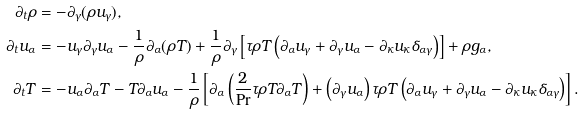Convert formula to latex. <formula><loc_0><loc_0><loc_500><loc_500>\partial _ { t } \rho & = - \partial _ { \gamma } ( \rho u _ { \gamma } ) , \\ \partial _ { t } u _ { \alpha } & = - u _ { \gamma } \partial _ { \gamma } u _ { \alpha } - \frac { 1 } { \rho } \partial _ { \alpha } ( \rho T ) + \frac { 1 } { \rho } \partial _ { \gamma } \left [ \tau \rho T \left ( \partial _ { \alpha } u _ { \gamma } + \partial _ { \gamma } u _ { \alpha } - \partial _ { \kappa } u _ { \kappa } \delta _ { \alpha \gamma } \right ) \right ] + \rho g _ { \alpha } , \\ \partial _ { t } T & = - u _ { \alpha } \partial _ { \alpha } T - T \partial _ { \alpha } u _ { \alpha } - \frac { 1 } { \rho } \left [ { \partial _ { \alpha } \left ( \frac { 2 } { \Pr } \tau \rho T \partial _ { \alpha } T \right ) + \left ( \partial _ { \gamma } u _ { \alpha } \right ) \tau \rho T \left ( \partial _ { \alpha } u _ { \gamma } + \partial _ { \gamma } u _ { \alpha } - \partial _ { \kappa } u _ { \kappa } \delta _ { \alpha \gamma } \right ) } \right ] .</formula> 